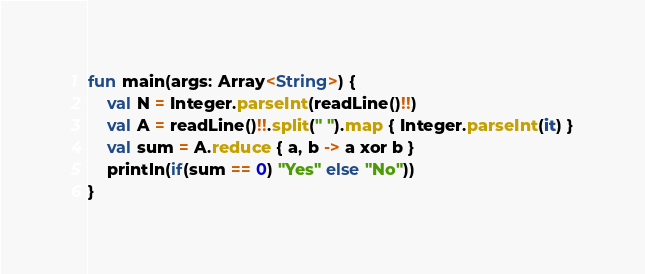Convert code to text. <code><loc_0><loc_0><loc_500><loc_500><_Kotlin_>fun main(args: Array<String>) {
    val N = Integer.parseInt(readLine()!!)
    val A = readLine()!!.split(" ").map { Integer.parseInt(it) }
    val sum = A.reduce { a, b -> a xor b }
    println(if(sum == 0) "Yes" else "No"))
}
</code> 